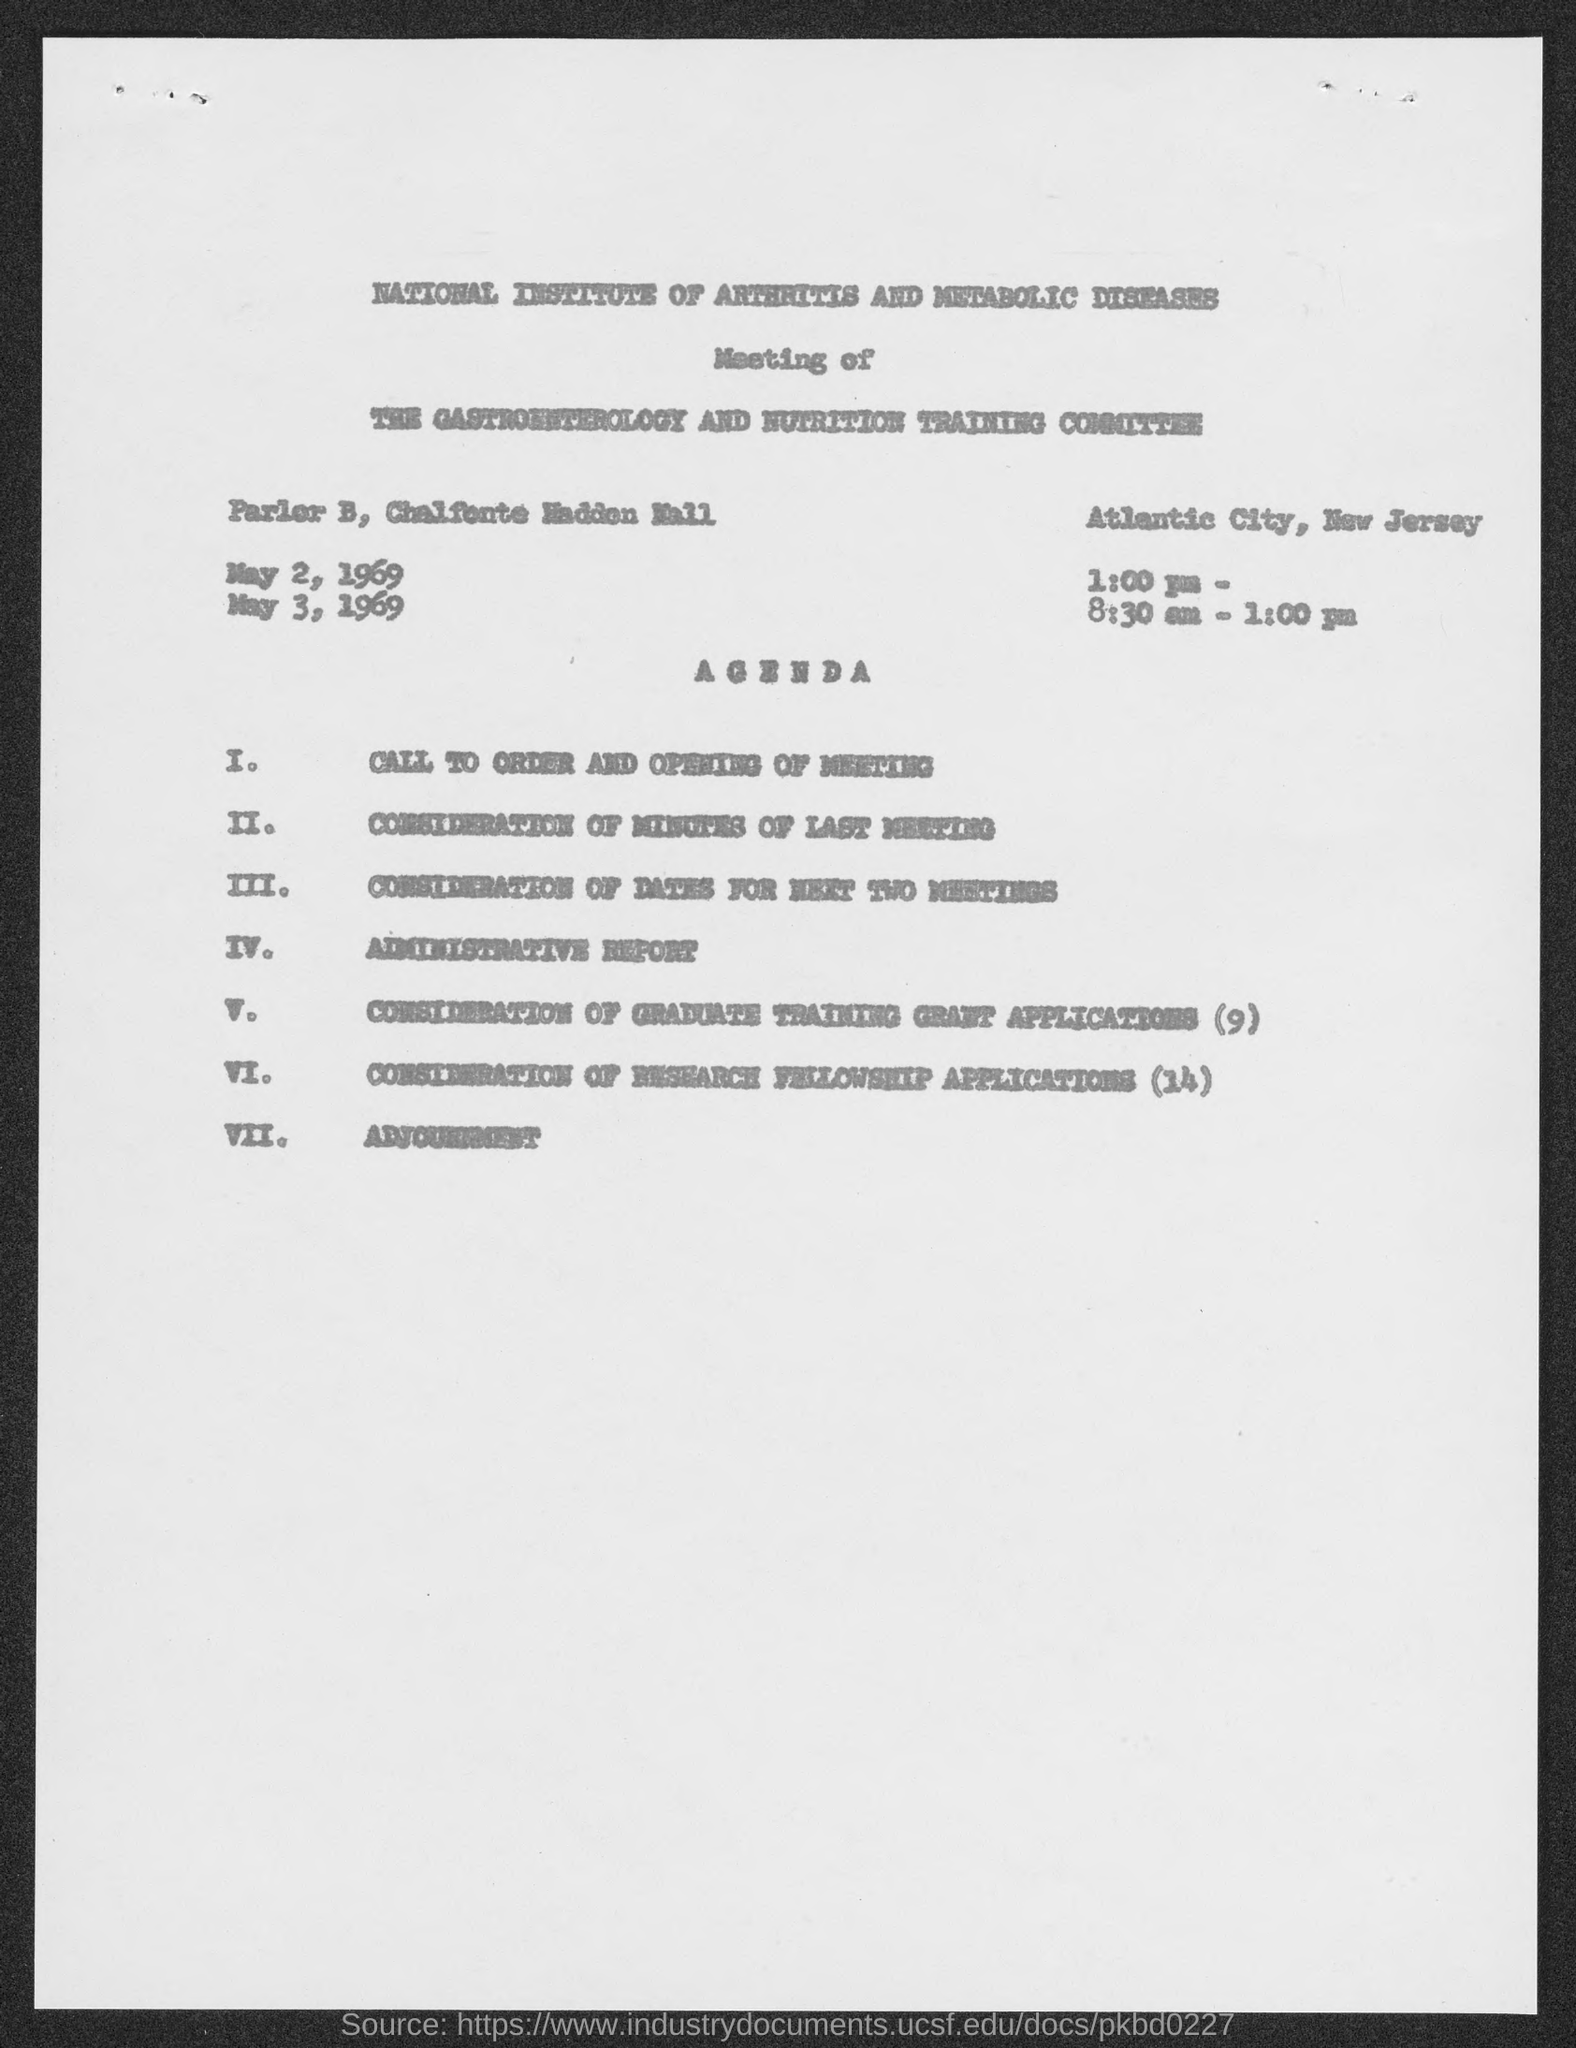What is the first title in the document?
Give a very brief answer. National Institute of Arthritis and Metabolic Diseases. What is the Agenda number VII?
Ensure brevity in your answer.  Adjournment. 